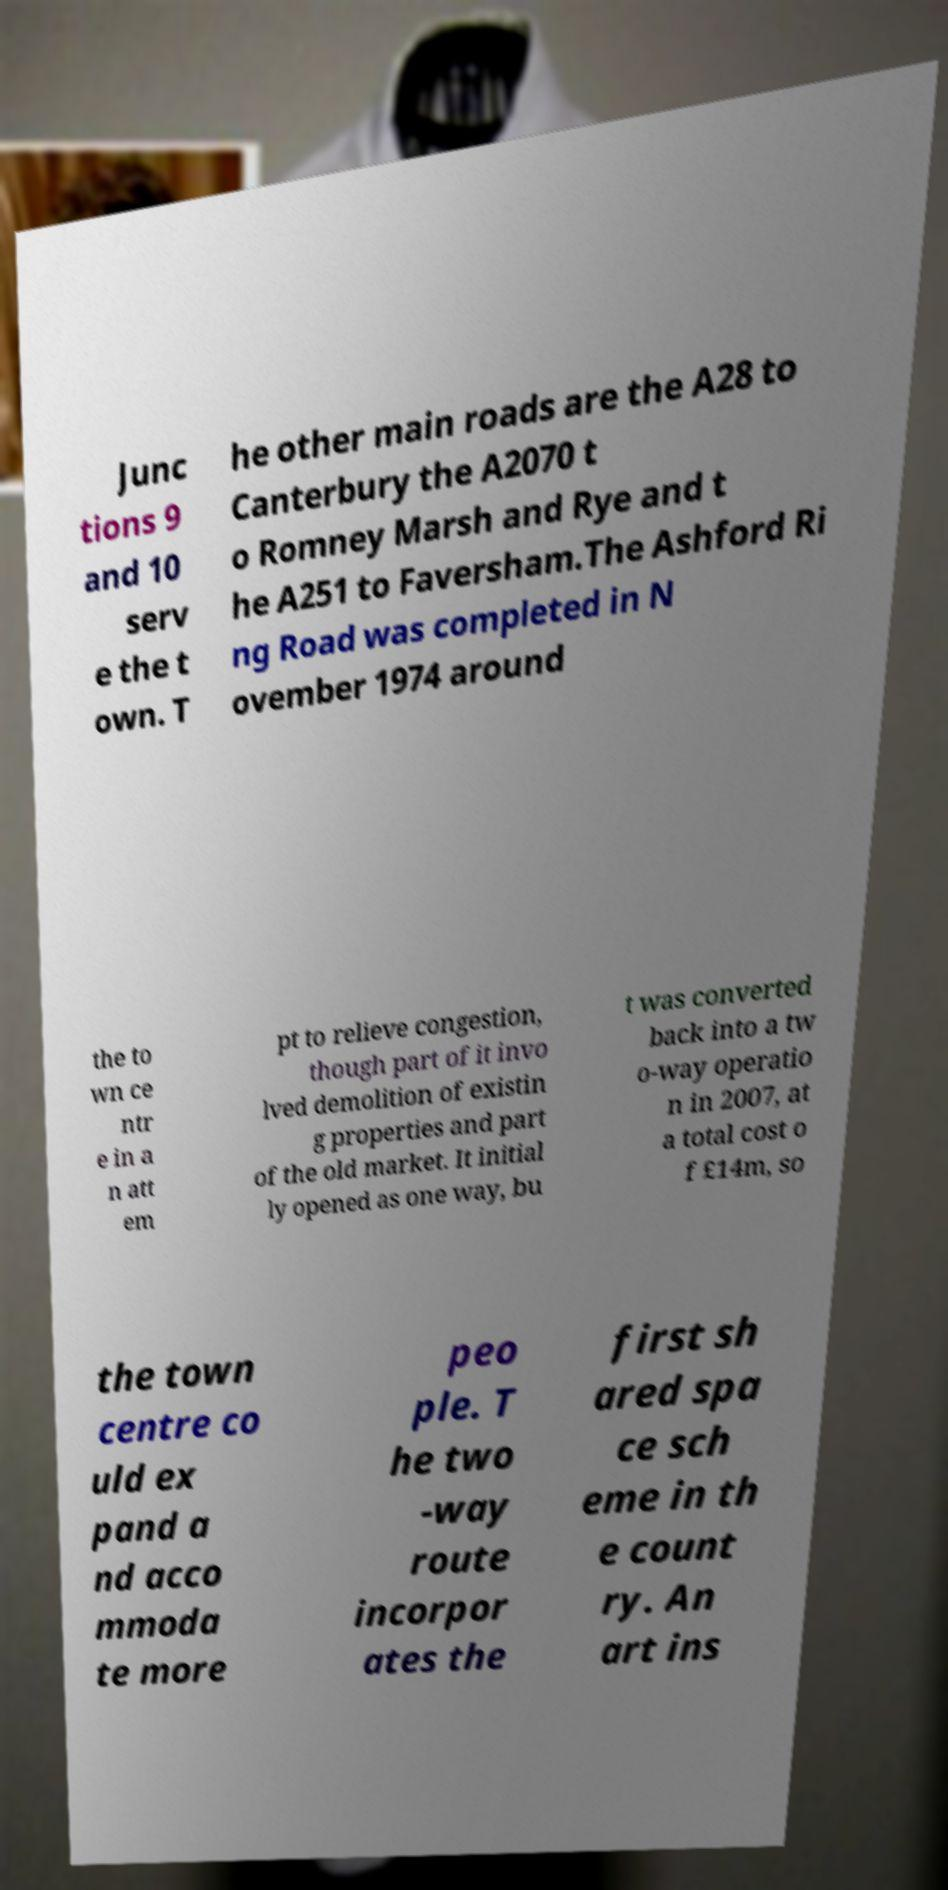Please identify and transcribe the text found in this image. Junc tions 9 and 10 serv e the t own. T he other main roads are the A28 to Canterbury the A2070 t o Romney Marsh and Rye and t he A251 to Faversham.The Ashford Ri ng Road was completed in N ovember 1974 around the to wn ce ntr e in a n att em pt to relieve congestion, though part of it invo lved demolition of existin g properties and part of the old market. It initial ly opened as one way, bu t was converted back into a tw o-way operatio n in 2007, at a total cost o f £14m, so the town centre co uld ex pand a nd acco mmoda te more peo ple. T he two -way route incorpor ates the first sh ared spa ce sch eme in th e count ry. An art ins 